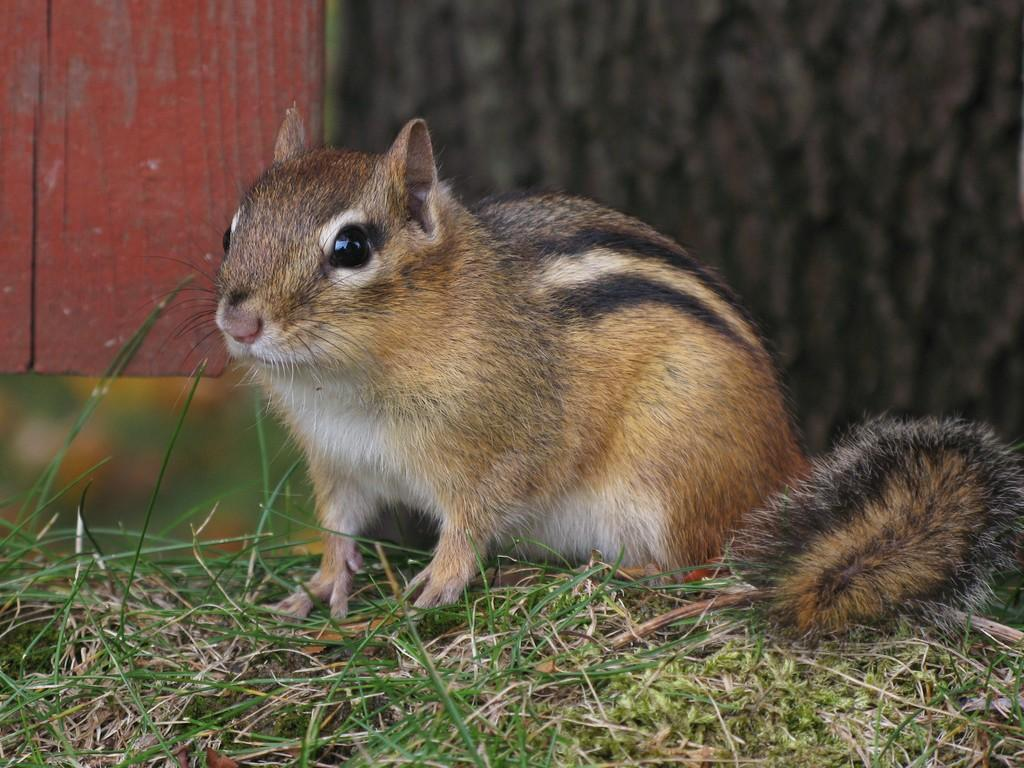What type of animal is in the image? There is a squirrel in the image. Where is the squirrel located? The squirrel is on the grass. What can be seen in the background of the image? There is a wall in the background of the image. What type of shock can be seen affecting the squirrel in the image? There is no shock present in the image; the squirrel is simply on the grass. What edge is the squirrel sitting on in the image? The squirrel is not sitting on an edge in the image; it is on the grass. 